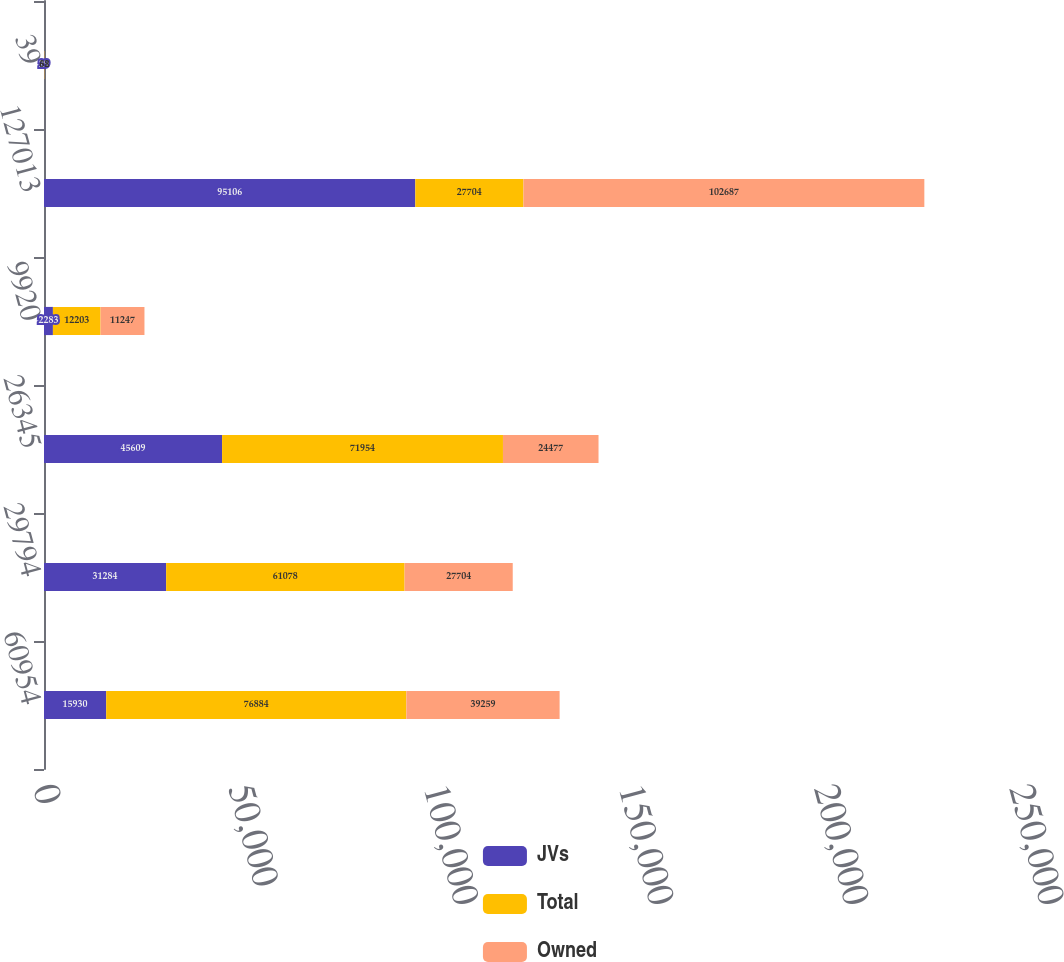<chart> <loc_0><loc_0><loc_500><loc_500><stacked_bar_chart><ecel><fcel>60954<fcel>29794<fcel>26345<fcel>9920<fcel>127013<fcel>39<nl><fcel>JVs<fcel>15930<fcel>31284<fcel>45609<fcel>2283<fcel>95106<fcel>29<nl><fcel>Total<fcel>76884<fcel>61078<fcel>71954<fcel>12203<fcel>27704<fcel>68<nl><fcel>Owned<fcel>39259<fcel>27704<fcel>24477<fcel>11247<fcel>102687<fcel>32<nl></chart> 